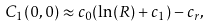<formula> <loc_0><loc_0><loc_500><loc_500>C _ { 1 } ( 0 , 0 ) \approx c _ { 0 } ( \ln ( R ) + c _ { 1 } ) - c _ { r } ,</formula> 